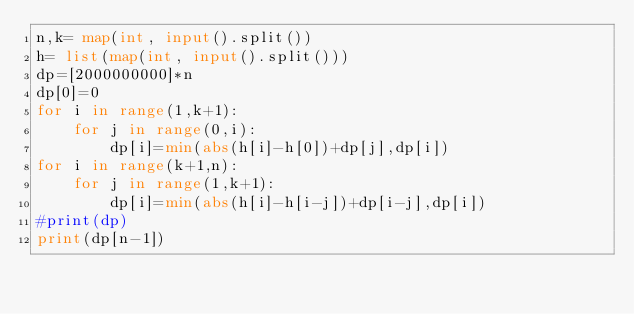Convert code to text. <code><loc_0><loc_0><loc_500><loc_500><_Python_>n,k= map(int, input().split())
h= list(map(int, input().split()))
dp=[2000000000]*n
dp[0]=0
for i in range(1,k+1):
    for j in range(0,i):
        dp[i]=min(abs(h[i]-h[0])+dp[j],dp[i])
for i in range(k+1,n):
    for j in range(1,k+1):
        dp[i]=min(abs(h[i]-h[i-j])+dp[i-j],dp[i])
#print(dp)
print(dp[n-1])</code> 